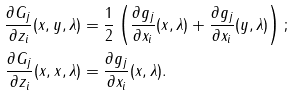<formula> <loc_0><loc_0><loc_500><loc_500>\frac { \partial G _ { j } } { \partial z _ { i } } ( x , y , \lambda ) & = \frac { 1 } { 2 } \left ( \frac { \partial g _ { j } } { \partial x _ { i } } ( x , \lambda ) + \frac { \partial g _ { j } } { \partial x _ { i } } ( y , \lambda ) \right ) ; \\ \frac { \partial G _ { j } } { \partial z _ { i } } ( x , x , \lambda ) & = \frac { \partial g _ { j } } { \partial x _ { i } } ( x , \lambda ) .</formula> 